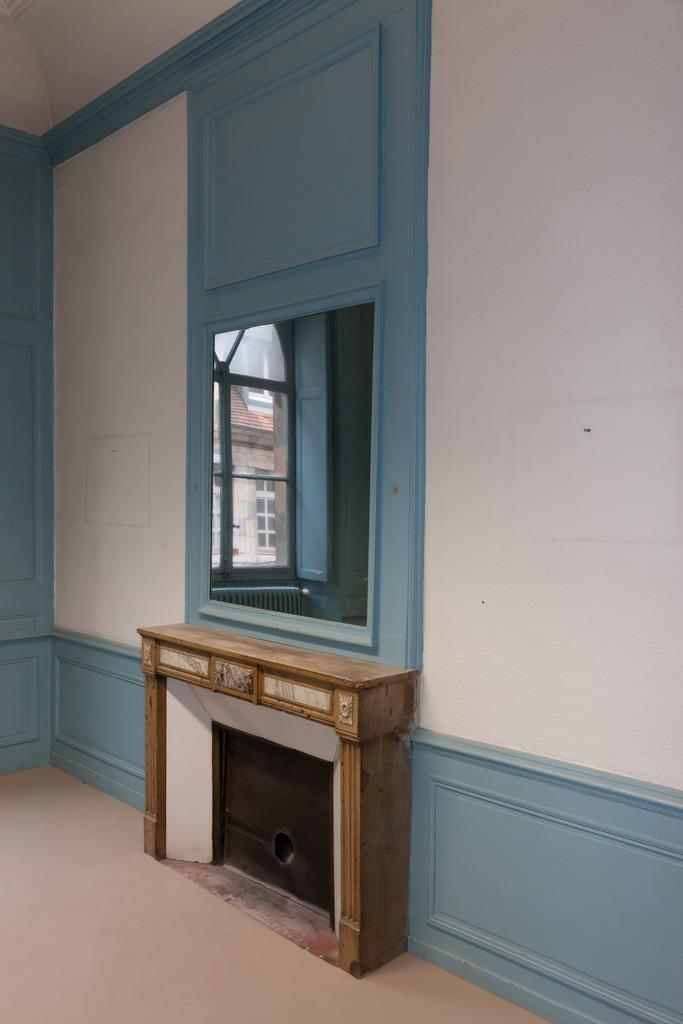What object is mounted on the wall in the image? There is a mirror on a wall in the image. What is placed beneath the mirror? There is a table placed under the mirror. What can be seen in the mirror's reflection? The reflection of a house and a window are visible in the mirror. How does the mirror sort thoughts in the image? The mirror does not sort thoughts in the image; it is a reflective surface that displays the reflection of objects in front of it. 